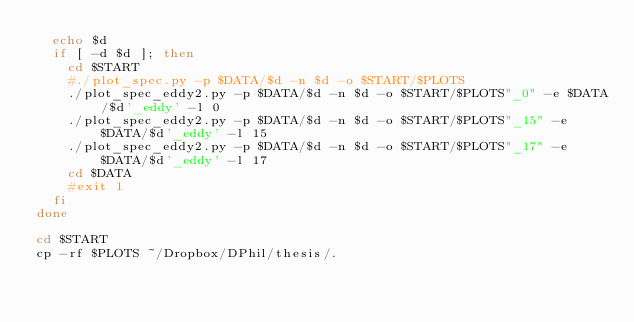Convert code to text. <code><loc_0><loc_0><loc_500><loc_500><_Bash_>  echo $d
  if [ -d $d ]; then
    cd $START 
    #./plot_spec.py -p $DATA/$d -n $d -o $START/$PLOTS
    ./plot_spec_eddy2.py -p $DATA/$d -n $d -o $START/$PLOTS"_0" -e $DATA/$d'_eddy' -l 0
    ./plot_spec_eddy2.py -p $DATA/$d -n $d -o $START/$PLOTS"_15" -e $DATA/$d'_eddy' -l 15
    ./plot_spec_eddy2.py -p $DATA/$d -n $d -o $START/$PLOTS"_17" -e $DATA/$d'_eddy' -l 17
    cd $DATA
    #exit 1
  fi
done

cd $START
cp -rf $PLOTS ~/Dropbox/DPhil/thesis/.
</code> 